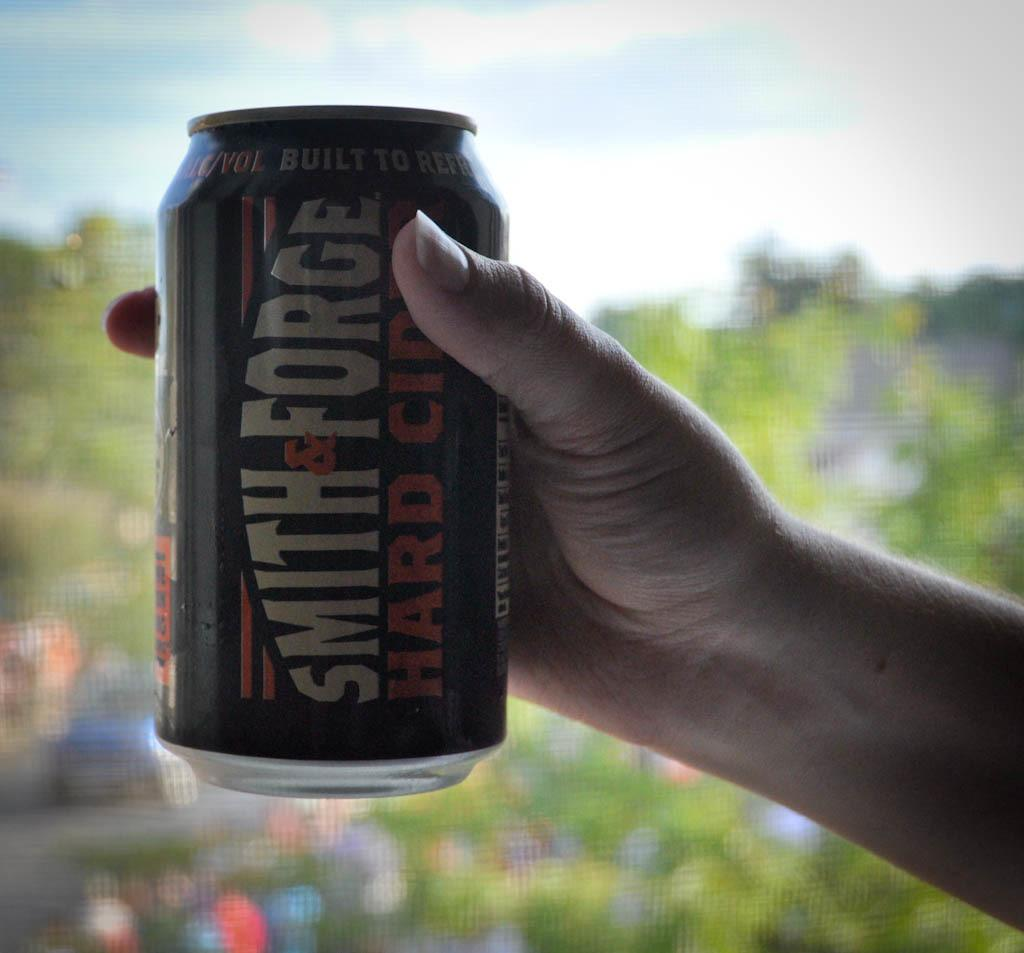<image>
Give a short and clear explanation of the subsequent image. A person's hand holding a large can of Smith and Forge Hard Cider. 